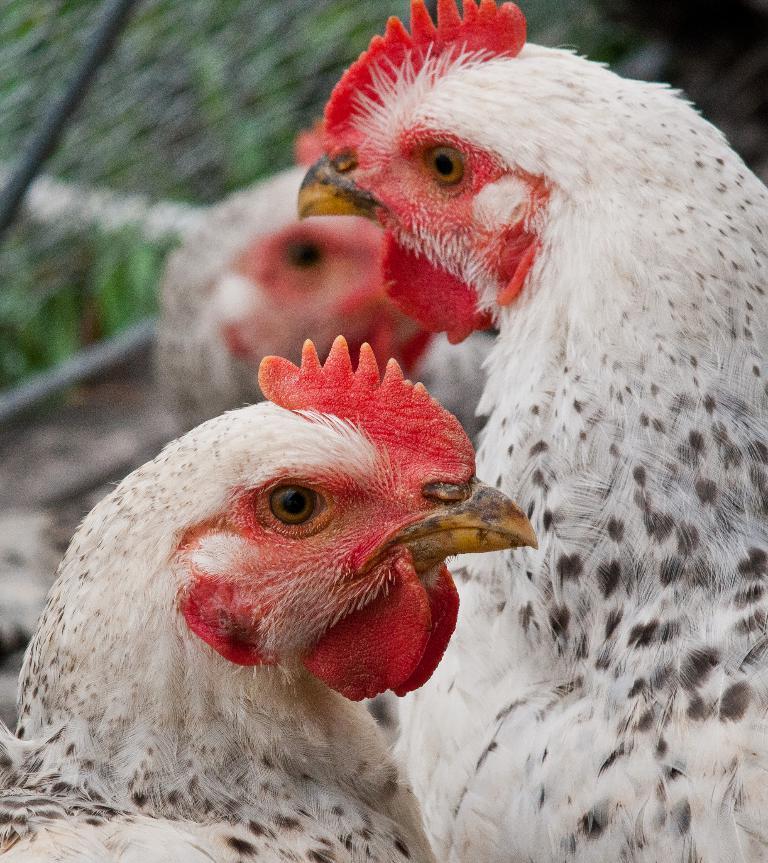Can you describe this image briefly? In the image there are two hens there are of white color and the background of the lens is blurry. 